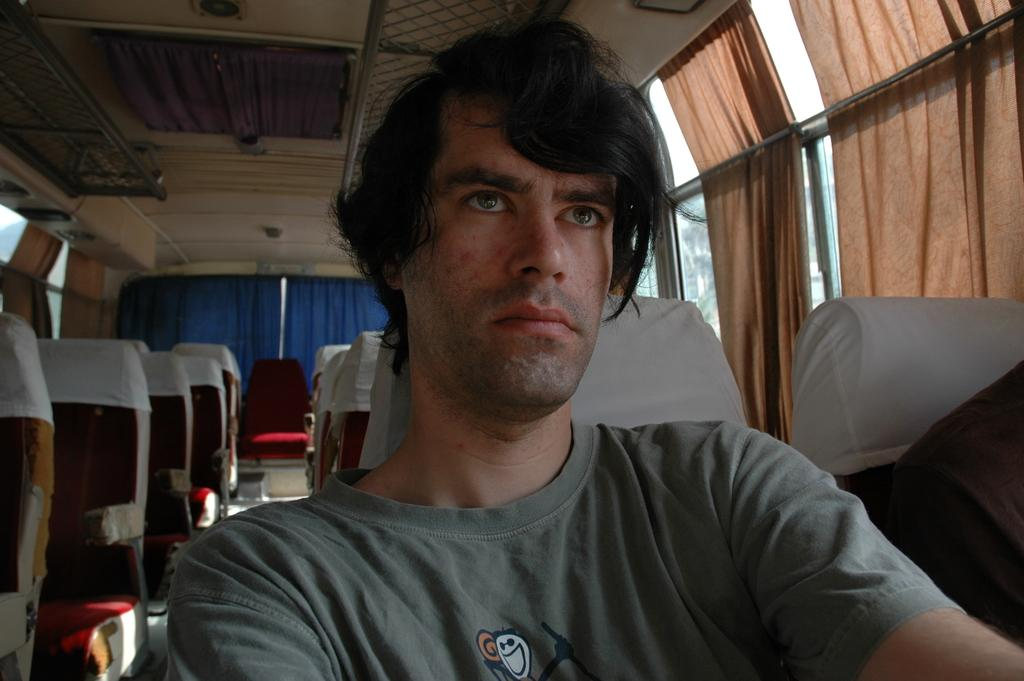Who is present in the image? There is a man in the image. Where is the man located? The man is sitting inside a bus. What can be seen in the background of the image? There are seats visible in the background of the image. What type of jelly is the man eating in the image? There is no jelly present in the image; the man is sitting inside a bus. 